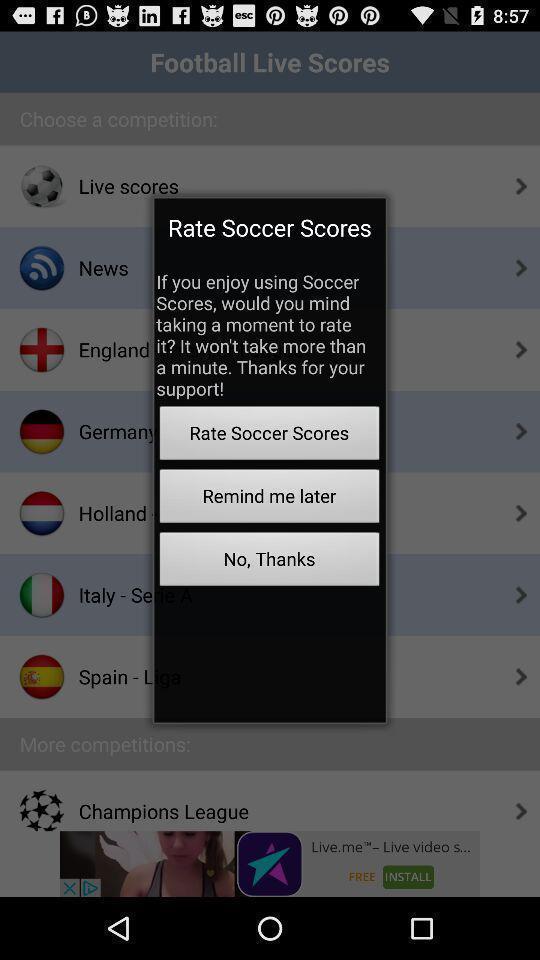Provide a detailed account of this screenshot. Pop-up showing an option to rate the scores. 